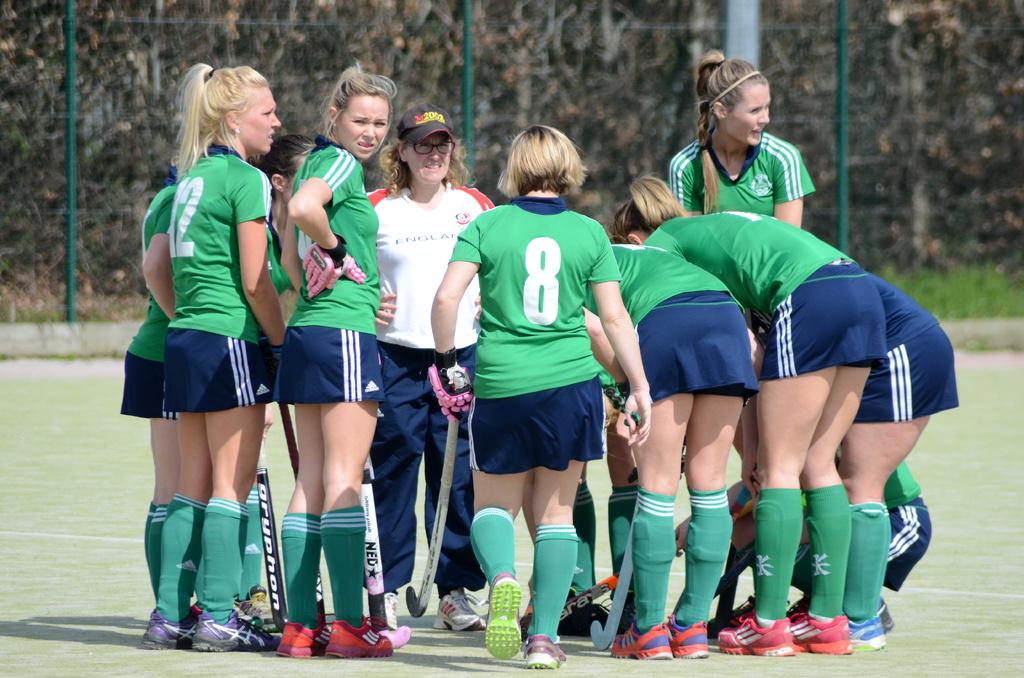How many people are not in a green shirt?
Provide a succinct answer. Answering does not require reading text in the image. 